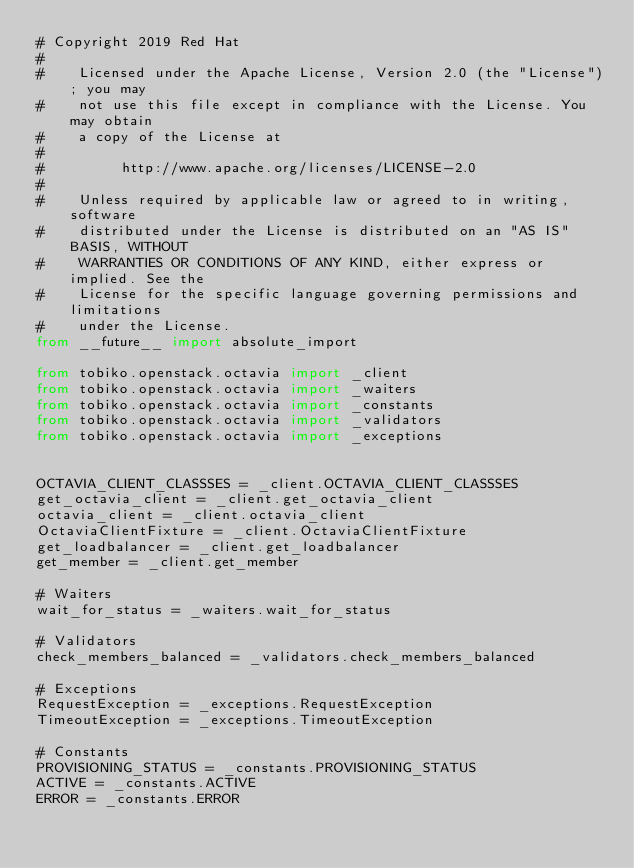<code> <loc_0><loc_0><loc_500><loc_500><_Python_># Copyright 2019 Red Hat
#
#    Licensed under the Apache License, Version 2.0 (the "License"); you may
#    not use this file except in compliance with the License. You may obtain
#    a copy of the License at
#
#         http://www.apache.org/licenses/LICENSE-2.0
#
#    Unless required by applicable law or agreed to in writing, software
#    distributed under the License is distributed on an "AS IS" BASIS, WITHOUT
#    WARRANTIES OR CONDITIONS OF ANY KIND, either express or implied. See the
#    License for the specific language governing permissions and limitations
#    under the License.
from __future__ import absolute_import

from tobiko.openstack.octavia import _client
from tobiko.openstack.octavia import _waiters
from tobiko.openstack.octavia import _constants
from tobiko.openstack.octavia import _validators
from tobiko.openstack.octavia import _exceptions


OCTAVIA_CLIENT_CLASSSES = _client.OCTAVIA_CLIENT_CLASSSES
get_octavia_client = _client.get_octavia_client
octavia_client = _client.octavia_client
OctaviaClientFixture = _client.OctaviaClientFixture
get_loadbalancer = _client.get_loadbalancer
get_member = _client.get_member

# Waiters
wait_for_status = _waiters.wait_for_status

# Validators
check_members_balanced = _validators.check_members_balanced

# Exceptions
RequestException = _exceptions.RequestException
TimeoutException = _exceptions.TimeoutException

# Constants
PROVISIONING_STATUS = _constants.PROVISIONING_STATUS
ACTIVE = _constants.ACTIVE
ERROR = _constants.ERROR
</code> 